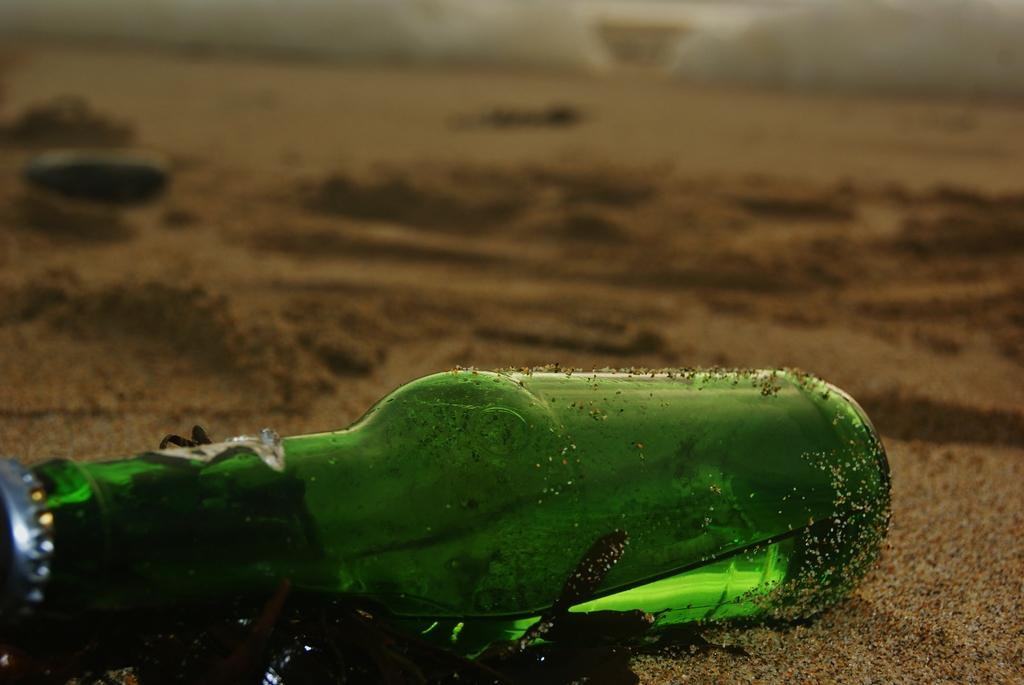What is in the image that contains a liquid? There is a bottle in the image that contains a drink. What is the surface on which the bottle is placed? The bottle is on a sand floor. How many eggs are being carried by the dolls in the image? There are no dolls or eggs present in the image. 